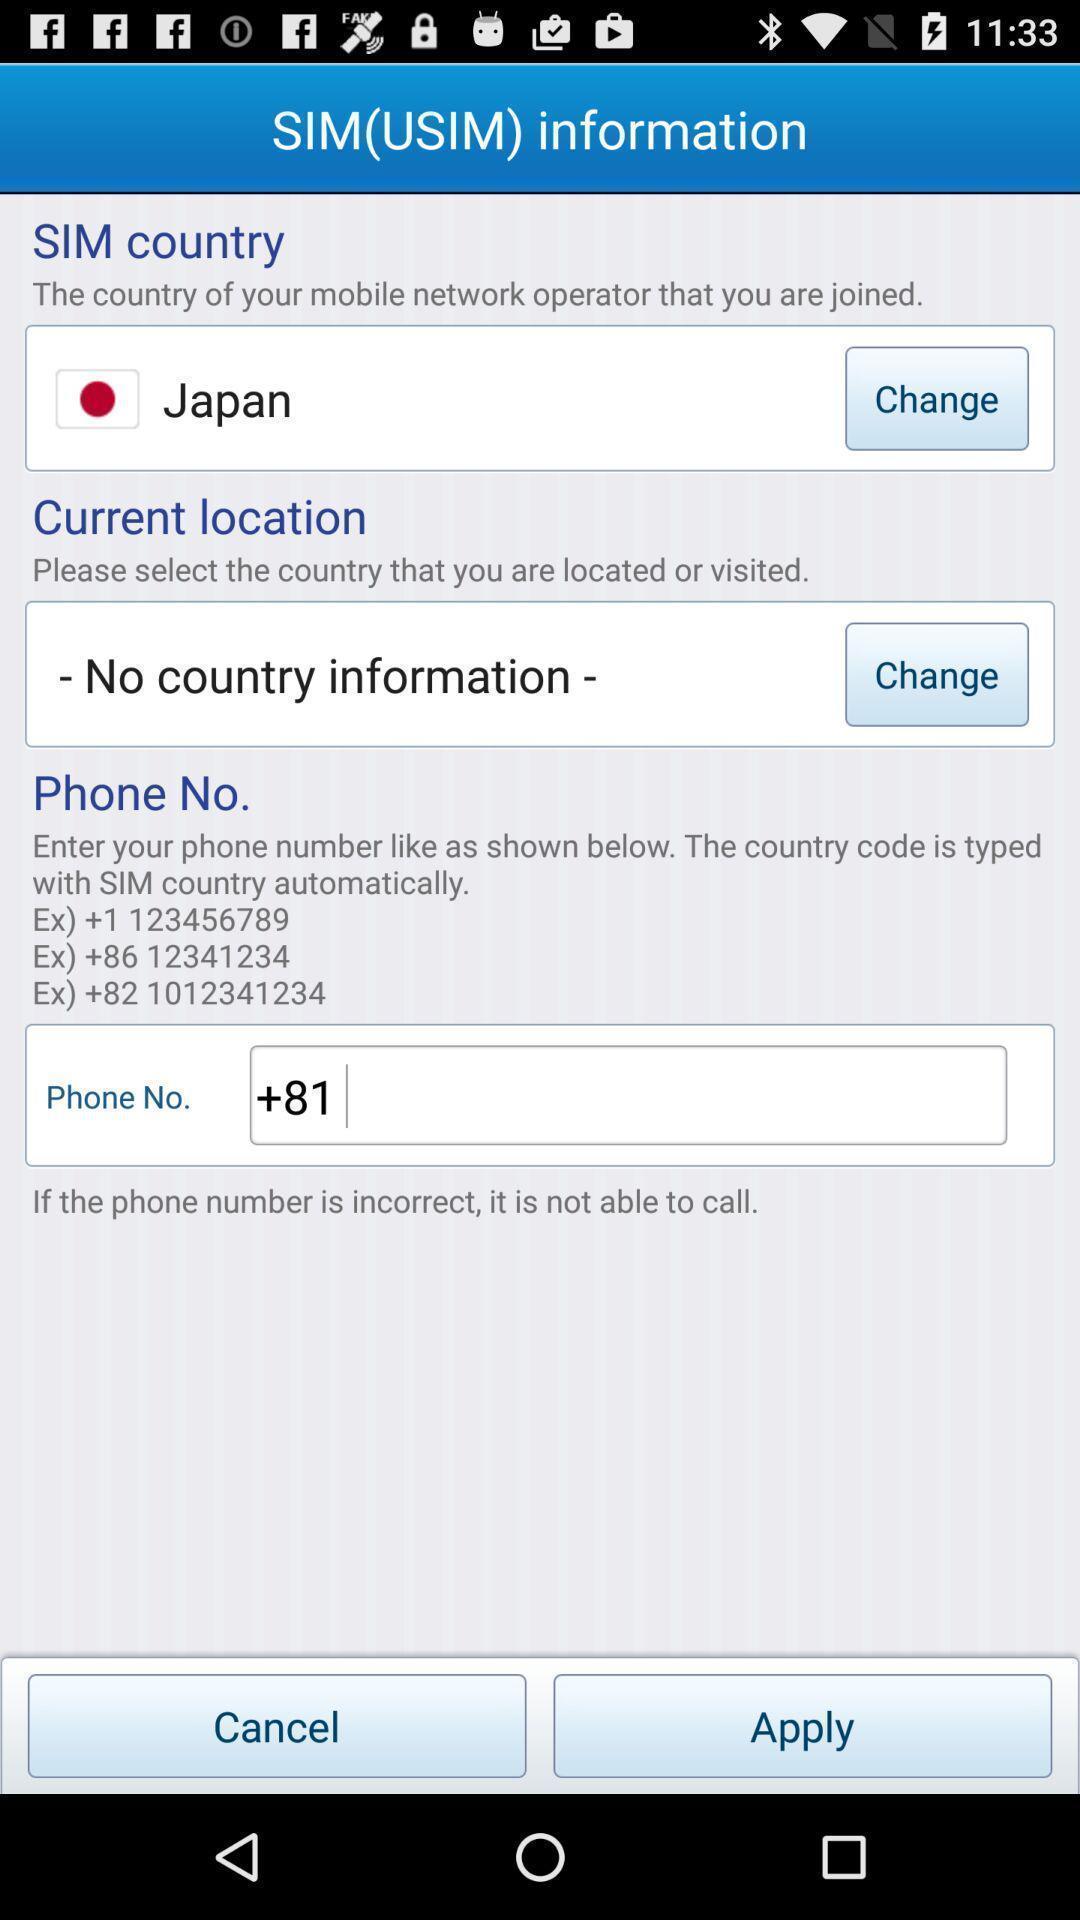Give me a narrative description of this picture. Screen showing info about the sim. 